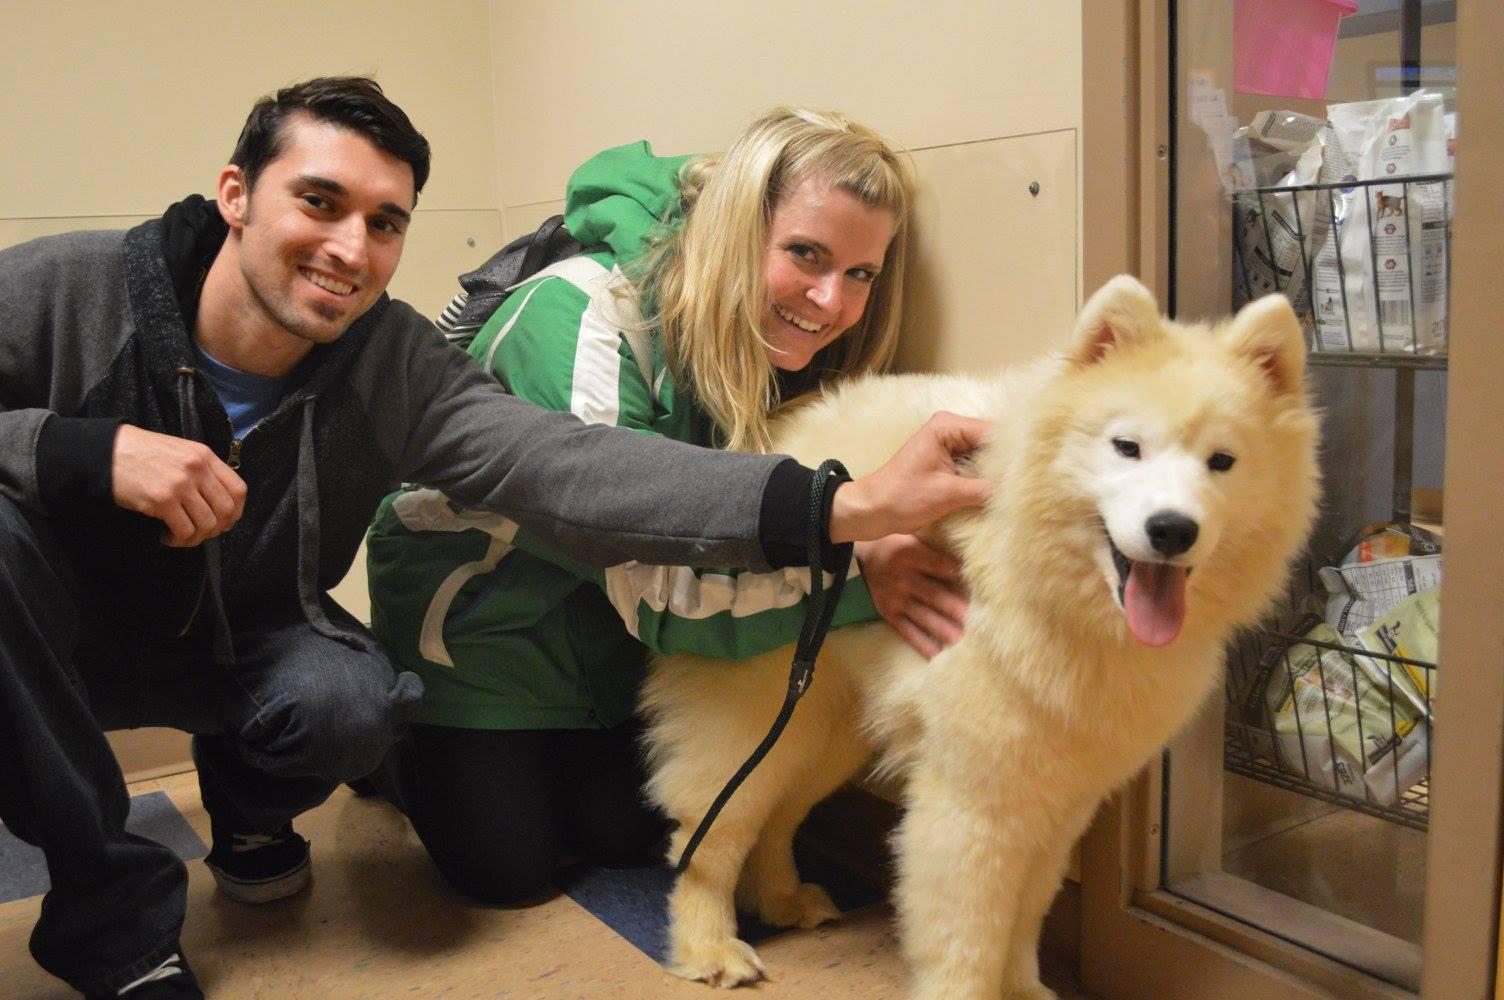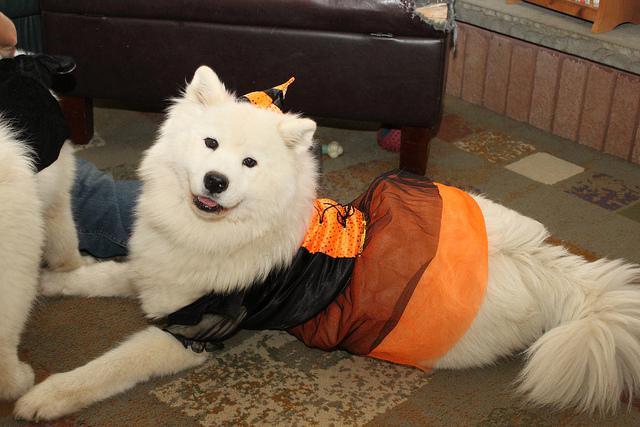The first image is the image on the left, the second image is the image on the right. For the images displayed, is the sentence "A white dog is wearing an orange and black Halloween costume that has a matching hat." factually correct? Answer yes or no. Yes. The first image is the image on the left, the second image is the image on the right. Considering the images on both sides, is "at least one dog is dressed in costume" valid? Answer yes or no. Yes. 